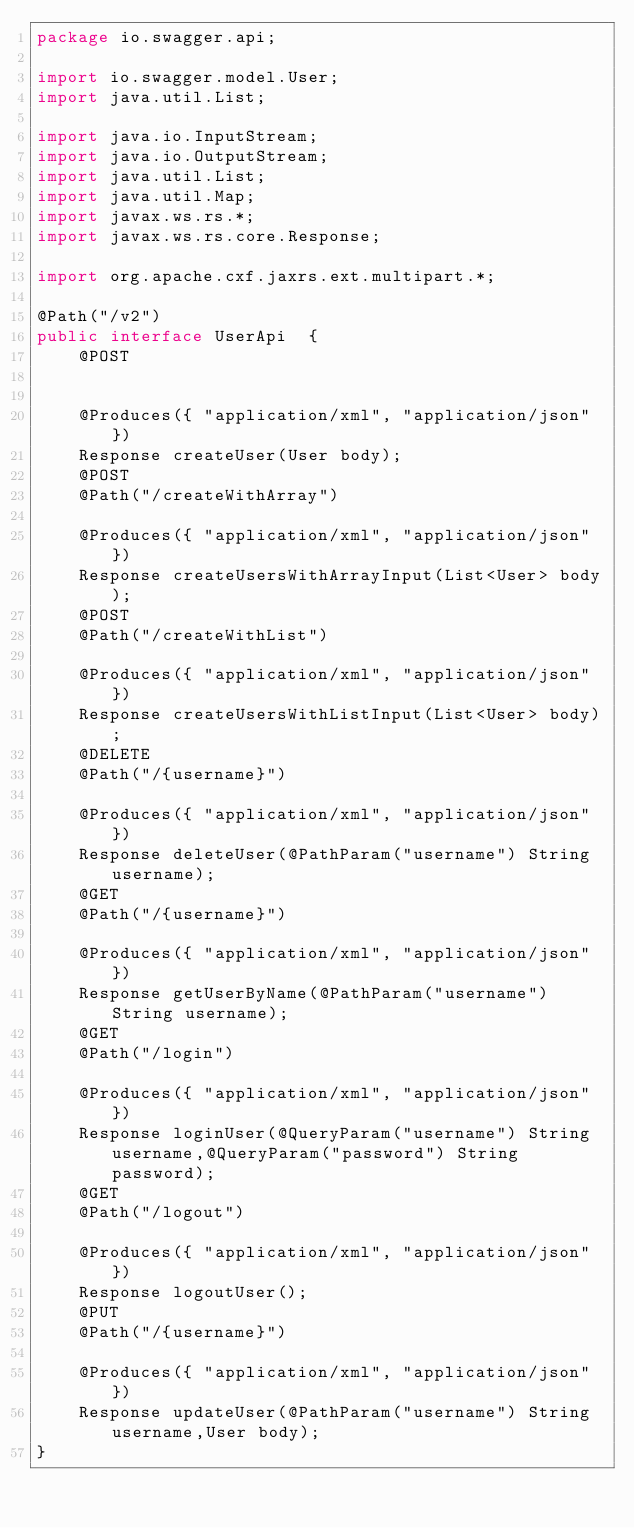Convert code to text. <code><loc_0><loc_0><loc_500><loc_500><_Java_>package io.swagger.api;

import io.swagger.model.User;
import java.util.List;

import java.io.InputStream;
import java.io.OutputStream;
import java.util.List;
import java.util.Map;
import javax.ws.rs.*;
import javax.ws.rs.core.Response;

import org.apache.cxf.jaxrs.ext.multipart.*;

@Path("/v2")
public interface UserApi  {
    @POST
    
    
    @Produces({ "application/xml", "application/json" })
    Response createUser(User body);
    @POST
    @Path("/createWithArray")
    
    @Produces({ "application/xml", "application/json" })
    Response createUsersWithArrayInput(List<User> body);
    @POST
    @Path("/createWithList")
    
    @Produces({ "application/xml", "application/json" })
    Response createUsersWithListInput(List<User> body);
    @DELETE
    @Path("/{username}")
    
    @Produces({ "application/xml", "application/json" })
    Response deleteUser(@PathParam("username") String username);
    @GET
    @Path("/{username}")
    
    @Produces({ "application/xml", "application/json" })
    Response getUserByName(@PathParam("username") String username);
    @GET
    @Path("/login")
    
    @Produces({ "application/xml", "application/json" })
    Response loginUser(@QueryParam("username") String username,@QueryParam("password") String password);
    @GET
    @Path("/logout")
    
    @Produces({ "application/xml", "application/json" })
    Response logoutUser();
    @PUT
    @Path("/{username}")
    
    @Produces({ "application/xml", "application/json" })
    Response updateUser(@PathParam("username") String username,User body);
}

</code> 